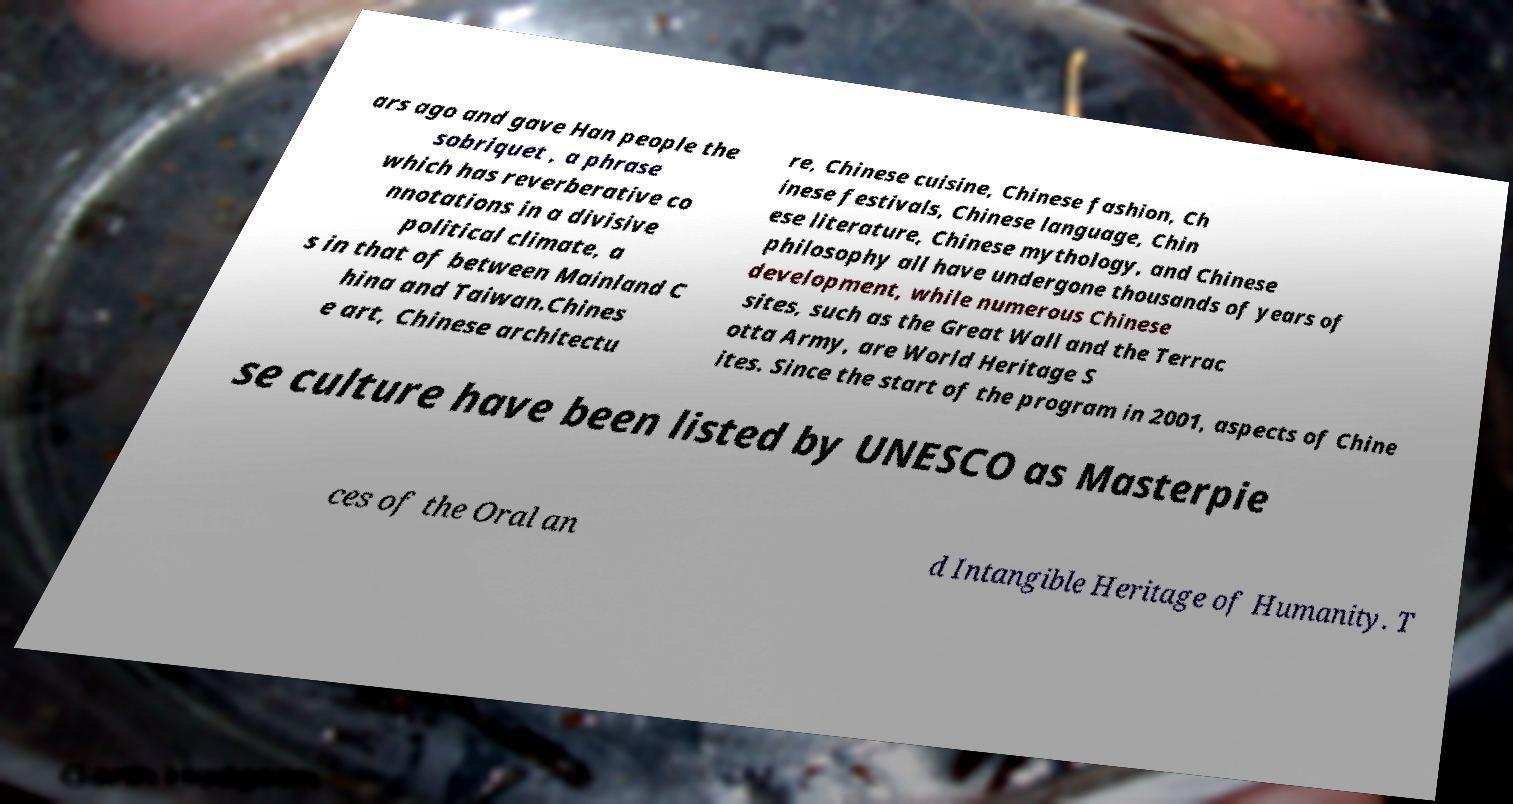Can you accurately transcribe the text from the provided image for me? ars ago and gave Han people the sobriquet , a phrase which has reverberative co nnotations in a divisive political climate, a s in that of between Mainland C hina and Taiwan.Chines e art, Chinese architectu re, Chinese cuisine, Chinese fashion, Ch inese festivals, Chinese language, Chin ese literature, Chinese mythology, and Chinese philosophy all have undergone thousands of years of development, while numerous Chinese sites, such as the Great Wall and the Terrac otta Army, are World Heritage S ites. Since the start of the program in 2001, aspects of Chine se culture have been listed by UNESCO as Masterpie ces of the Oral an d Intangible Heritage of Humanity. T 